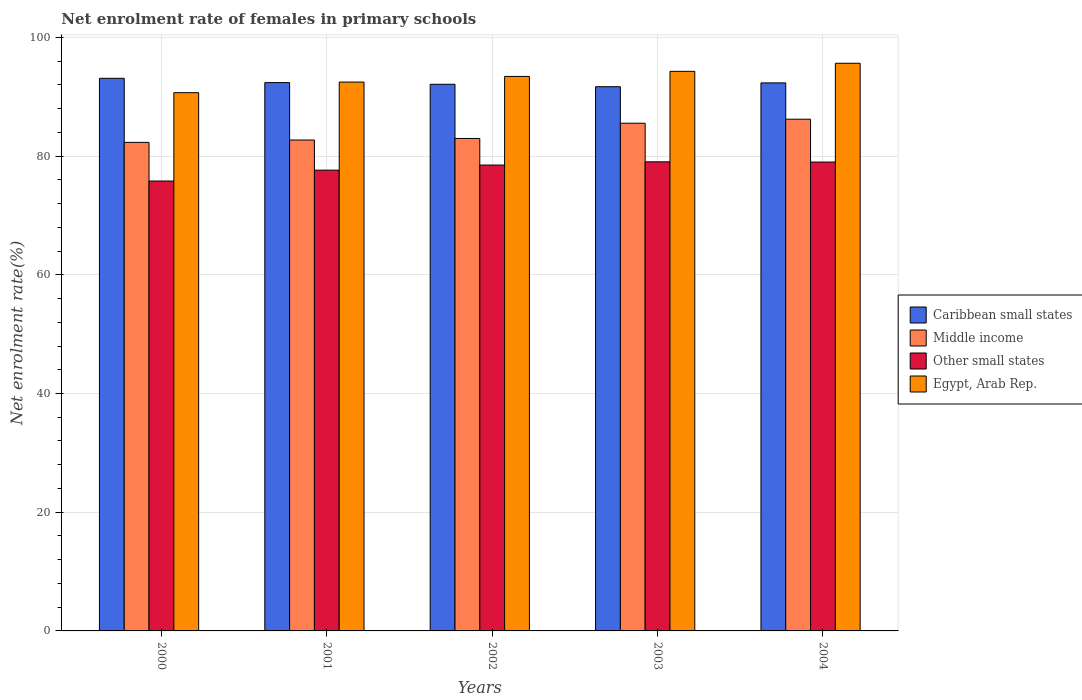Are the number of bars per tick equal to the number of legend labels?
Give a very brief answer. Yes. How many bars are there on the 3rd tick from the left?
Your response must be concise. 4. How many bars are there on the 4th tick from the right?
Ensure brevity in your answer.  4. In how many cases, is the number of bars for a given year not equal to the number of legend labels?
Give a very brief answer. 0. What is the net enrolment rate of females in primary schools in Other small states in 2002?
Ensure brevity in your answer.  78.48. Across all years, what is the maximum net enrolment rate of females in primary schools in Egypt, Arab Rep.?
Your response must be concise. 95.64. Across all years, what is the minimum net enrolment rate of females in primary schools in Egypt, Arab Rep.?
Your answer should be compact. 90.68. What is the total net enrolment rate of females in primary schools in Egypt, Arab Rep. in the graph?
Your answer should be compact. 466.47. What is the difference between the net enrolment rate of females in primary schools in Middle income in 2002 and that in 2004?
Your response must be concise. -3.25. What is the difference between the net enrolment rate of females in primary schools in Other small states in 2000 and the net enrolment rate of females in primary schools in Egypt, Arab Rep. in 2003?
Keep it short and to the point. -18.48. What is the average net enrolment rate of females in primary schools in Middle income per year?
Your answer should be very brief. 83.94. In the year 2001, what is the difference between the net enrolment rate of females in primary schools in Egypt, Arab Rep. and net enrolment rate of females in primary schools in Caribbean small states?
Keep it short and to the point. 0.09. What is the ratio of the net enrolment rate of females in primary schools in Caribbean small states in 2002 to that in 2003?
Offer a terse response. 1. What is the difference between the highest and the second highest net enrolment rate of females in primary schools in Caribbean small states?
Give a very brief answer. 0.72. What is the difference between the highest and the lowest net enrolment rate of females in primary schools in Caribbean small states?
Offer a very short reply. 1.41. Is the sum of the net enrolment rate of females in primary schools in Other small states in 2002 and 2004 greater than the maximum net enrolment rate of females in primary schools in Caribbean small states across all years?
Provide a short and direct response. Yes. What does the 2nd bar from the left in 2000 represents?
Provide a short and direct response. Middle income. What does the 1st bar from the right in 2000 represents?
Make the answer very short. Egypt, Arab Rep. How many bars are there?
Provide a succinct answer. 20. Are all the bars in the graph horizontal?
Your response must be concise. No. Are the values on the major ticks of Y-axis written in scientific E-notation?
Make the answer very short. No. Does the graph contain grids?
Offer a terse response. Yes. How are the legend labels stacked?
Provide a short and direct response. Vertical. What is the title of the graph?
Provide a succinct answer. Net enrolment rate of females in primary schools. Does "Germany" appear as one of the legend labels in the graph?
Your answer should be very brief. No. What is the label or title of the Y-axis?
Ensure brevity in your answer.  Net enrolment rate(%). What is the Net enrolment rate(%) of Caribbean small states in 2000?
Make the answer very short. 93.1. What is the Net enrolment rate(%) of Middle income in 2000?
Your answer should be compact. 82.31. What is the Net enrolment rate(%) in Other small states in 2000?
Keep it short and to the point. 75.79. What is the Net enrolment rate(%) in Egypt, Arab Rep. in 2000?
Make the answer very short. 90.68. What is the Net enrolment rate(%) in Caribbean small states in 2001?
Keep it short and to the point. 92.38. What is the Net enrolment rate(%) of Middle income in 2001?
Your response must be concise. 82.7. What is the Net enrolment rate(%) in Other small states in 2001?
Offer a very short reply. 77.63. What is the Net enrolment rate(%) in Egypt, Arab Rep. in 2001?
Your response must be concise. 92.46. What is the Net enrolment rate(%) of Caribbean small states in 2002?
Ensure brevity in your answer.  92.09. What is the Net enrolment rate(%) of Middle income in 2002?
Your response must be concise. 82.97. What is the Net enrolment rate(%) of Other small states in 2002?
Offer a very short reply. 78.48. What is the Net enrolment rate(%) in Egypt, Arab Rep. in 2002?
Offer a terse response. 93.42. What is the Net enrolment rate(%) in Caribbean small states in 2003?
Keep it short and to the point. 91.69. What is the Net enrolment rate(%) in Middle income in 2003?
Ensure brevity in your answer.  85.53. What is the Net enrolment rate(%) in Other small states in 2003?
Your answer should be compact. 79.03. What is the Net enrolment rate(%) of Egypt, Arab Rep. in 2003?
Your answer should be very brief. 94.27. What is the Net enrolment rate(%) in Caribbean small states in 2004?
Give a very brief answer. 92.33. What is the Net enrolment rate(%) of Middle income in 2004?
Your response must be concise. 86.21. What is the Net enrolment rate(%) of Other small states in 2004?
Give a very brief answer. 78.99. What is the Net enrolment rate(%) of Egypt, Arab Rep. in 2004?
Ensure brevity in your answer.  95.64. Across all years, what is the maximum Net enrolment rate(%) in Caribbean small states?
Give a very brief answer. 93.1. Across all years, what is the maximum Net enrolment rate(%) in Middle income?
Give a very brief answer. 86.21. Across all years, what is the maximum Net enrolment rate(%) in Other small states?
Your response must be concise. 79.03. Across all years, what is the maximum Net enrolment rate(%) of Egypt, Arab Rep.?
Provide a short and direct response. 95.64. Across all years, what is the minimum Net enrolment rate(%) in Caribbean small states?
Provide a short and direct response. 91.69. Across all years, what is the minimum Net enrolment rate(%) of Middle income?
Make the answer very short. 82.31. Across all years, what is the minimum Net enrolment rate(%) of Other small states?
Ensure brevity in your answer.  75.79. Across all years, what is the minimum Net enrolment rate(%) of Egypt, Arab Rep.?
Make the answer very short. 90.68. What is the total Net enrolment rate(%) of Caribbean small states in the graph?
Make the answer very short. 461.58. What is the total Net enrolment rate(%) in Middle income in the graph?
Your response must be concise. 419.72. What is the total Net enrolment rate(%) in Other small states in the graph?
Ensure brevity in your answer.  389.93. What is the total Net enrolment rate(%) of Egypt, Arab Rep. in the graph?
Keep it short and to the point. 466.47. What is the difference between the Net enrolment rate(%) of Caribbean small states in 2000 and that in 2001?
Offer a terse response. 0.72. What is the difference between the Net enrolment rate(%) of Middle income in 2000 and that in 2001?
Give a very brief answer. -0.4. What is the difference between the Net enrolment rate(%) of Other small states in 2000 and that in 2001?
Ensure brevity in your answer.  -1.83. What is the difference between the Net enrolment rate(%) of Egypt, Arab Rep. in 2000 and that in 2001?
Provide a succinct answer. -1.79. What is the difference between the Net enrolment rate(%) of Middle income in 2000 and that in 2002?
Give a very brief answer. -0.66. What is the difference between the Net enrolment rate(%) of Other small states in 2000 and that in 2002?
Provide a short and direct response. -2.69. What is the difference between the Net enrolment rate(%) in Egypt, Arab Rep. in 2000 and that in 2002?
Make the answer very short. -2.74. What is the difference between the Net enrolment rate(%) of Caribbean small states in 2000 and that in 2003?
Make the answer very short. 1.41. What is the difference between the Net enrolment rate(%) of Middle income in 2000 and that in 2003?
Make the answer very short. -3.23. What is the difference between the Net enrolment rate(%) in Other small states in 2000 and that in 2003?
Give a very brief answer. -3.24. What is the difference between the Net enrolment rate(%) in Egypt, Arab Rep. in 2000 and that in 2003?
Offer a very short reply. -3.6. What is the difference between the Net enrolment rate(%) in Caribbean small states in 2000 and that in 2004?
Ensure brevity in your answer.  0.77. What is the difference between the Net enrolment rate(%) in Middle income in 2000 and that in 2004?
Keep it short and to the point. -3.9. What is the difference between the Net enrolment rate(%) of Other small states in 2000 and that in 2004?
Provide a short and direct response. -3.2. What is the difference between the Net enrolment rate(%) of Egypt, Arab Rep. in 2000 and that in 2004?
Your response must be concise. -4.96. What is the difference between the Net enrolment rate(%) of Caribbean small states in 2001 and that in 2002?
Provide a short and direct response. 0.28. What is the difference between the Net enrolment rate(%) of Middle income in 2001 and that in 2002?
Offer a terse response. -0.26. What is the difference between the Net enrolment rate(%) of Other small states in 2001 and that in 2002?
Make the answer very short. -0.86. What is the difference between the Net enrolment rate(%) of Egypt, Arab Rep. in 2001 and that in 2002?
Your answer should be compact. -0.95. What is the difference between the Net enrolment rate(%) of Caribbean small states in 2001 and that in 2003?
Your answer should be very brief. 0.69. What is the difference between the Net enrolment rate(%) of Middle income in 2001 and that in 2003?
Your response must be concise. -2.83. What is the difference between the Net enrolment rate(%) in Other small states in 2001 and that in 2003?
Your response must be concise. -1.4. What is the difference between the Net enrolment rate(%) of Egypt, Arab Rep. in 2001 and that in 2003?
Make the answer very short. -1.81. What is the difference between the Net enrolment rate(%) of Caribbean small states in 2001 and that in 2004?
Offer a terse response. 0.05. What is the difference between the Net enrolment rate(%) of Middle income in 2001 and that in 2004?
Ensure brevity in your answer.  -3.51. What is the difference between the Net enrolment rate(%) in Other small states in 2001 and that in 2004?
Your response must be concise. -1.36. What is the difference between the Net enrolment rate(%) of Egypt, Arab Rep. in 2001 and that in 2004?
Keep it short and to the point. -3.17. What is the difference between the Net enrolment rate(%) in Caribbean small states in 2002 and that in 2003?
Your answer should be compact. 0.41. What is the difference between the Net enrolment rate(%) in Middle income in 2002 and that in 2003?
Offer a terse response. -2.57. What is the difference between the Net enrolment rate(%) in Other small states in 2002 and that in 2003?
Keep it short and to the point. -0.55. What is the difference between the Net enrolment rate(%) of Egypt, Arab Rep. in 2002 and that in 2003?
Offer a very short reply. -0.86. What is the difference between the Net enrolment rate(%) in Caribbean small states in 2002 and that in 2004?
Offer a terse response. -0.23. What is the difference between the Net enrolment rate(%) in Middle income in 2002 and that in 2004?
Make the answer very short. -3.25. What is the difference between the Net enrolment rate(%) in Other small states in 2002 and that in 2004?
Give a very brief answer. -0.51. What is the difference between the Net enrolment rate(%) of Egypt, Arab Rep. in 2002 and that in 2004?
Make the answer very short. -2.22. What is the difference between the Net enrolment rate(%) in Caribbean small states in 2003 and that in 2004?
Offer a terse response. -0.64. What is the difference between the Net enrolment rate(%) of Middle income in 2003 and that in 2004?
Keep it short and to the point. -0.68. What is the difference between the Net enrolment rate(%) of Other small states in 2003 and that in 2004?
Your answer should be compact. 0.04. What is the difference between the Net enrolment rate(%) in Egypt, Arab Rep. in 2003 and that in 2004?
Offer a terse response. -1.36. What is the difference between the Net enrolment rate(%) in Caribbean small states in 2000 and the Net enrolment rate(%) in Middle income in 2001?
Offer a very short reply. 10.39. What is the difference between the Net enrolment rate(%) in Caribbean small states in 2000 and the Net enrolment rate(%) in Other small states in 2001?
Ensure brevity in your answer.  15.47. What is the difference between the Net enrolment rate(%) in Caribbean small states in 2000 and the Net enrolment rate(%) in Egypt, Arab Rep. in 2001?
Give a very brief answer. 0.63. What is the difference between the Net enrolment rate(%) of Middle income in 2000 and the Net enrolment rate(%) of Other small states in 2001?
Make the answer very short. 4.68. What is the difference between the Net enrolment rate(%) in Middle income in 2000 and the Net enrolment rate(%) in Egypt, Arab Rep. in 2001?
Your answer should be compact. -10.16. What is the difference between the Net enrolment rate(%) in Other small states in 2000 and the Net enrolment rate(%) in Egypt, Arab Rep. in 2001?
Provide a succinct answer. -16.67. What is the difference between the Net enrolment rate(%) in Caribbean small states in 2000 and the Net enrolment rate(%) in Middle income in 2002?
Your answer should be very brief. 10.13. What is the difference between the Net enrolment rate(%) in Caribbean small states in 2000 and the Net enrolment rate(%) in Other small states in 2002?
Your answer should be compact. 14.61. What is the difference between the Net enrolment rate(%) of Caribbean small states in 2000 and the Net enrolment rate(%) of Egypt, Arab Rep. in 2002?
Ensure brevity in your answer.  -0.32. What is the difference between the Net enrolment rate(%) of Middle income in 2000 and the Net enrolment rate(%) of Other small states in 2002?
Provide a succinct answer. 3.82. What is the difference between the Net enrolment rate(%) of Middle income in 2000 and the Net enrolment rate(%) of Egypt, Arab Rep. in 2002?
Your response must be concise. -11.11. What is the difference between the Net enrolment rate(%) of Other small states in 2000 and the Net enrolment rate(%) of Egypt, Arab Rep. in 2002?
Your answer should be compact. -17.62. What is the difference between the Net enrolment rate(%) of Caribbean small states in 2000 and the Net enrolment rate(%) of Middle income in 2003?
Offer a terse response. 7.56. What is the difference between the Net enrolment rate(%) of Caribbean small states in 2000 and the Net enrolment rate(%) of Other small states in 2003?
Provide a succinct answer. 14.07. What is the difference between the Net enrolment rate(%) in Caribbean small states in 2000 and the Net enrolment rate(%) in Egypt, Arab Rep. in 2003?
Ensure brevity in your answer.  -1.18. What is the difference between the Net enrolment rate(%) of Middle income in 2000 and the Net enrolment rate(%) of Other small states in 2003?
Ensure brevity in your answer.  3.28. What is the difference between the Net enrolment rate(%) of Middle income in 2000 and the Net enrolment rate(%) of Egypt, Arab Rep. in 2003?
Offer a terse response. -11.97. What is the difference between the Net enrolment rate(%) in Other small states in 2000 and the Net enrolment rate(%) in Egypt, Arab Rep. in 2003?
Make the answer very short. -18.48. What is the difference between the Net enrolment rate(%) in Caribbean small states in 2000 and the Net enrolment rate(%) in Middle income in 2004?
Give a very brief answer. 6.88. What is the difference between the Net enrolment rate(%) of Caribbean small states in 2000 and the Net enrolment rate(%) of Other small states in 2004?
Provide a succinct answer. 14.11. What is the difference between the Net enrolment rate(%) in Caribbean small states in 2000 and the Net enrolment rate(%) in Egypt, Arab Rep. in 2004?
Your answer should be compact. -2.54. What is the difference between the Net enrolment rate(%) in Middle income in 2000 and the Net enrolment rate(%) in Other small states in 2004?
Ensure brevity in your answer.  3.32. What is the difference between the Net enrolment rate(%) in Middle income in 2000 and the Net enrolment rate(%) in Egypt, Arab Rep. in 2004?
Your answer should be very brief. -13.33. What is the difference between the Net enrolment rate(%) of Other small states in 2000 and the Net enrolment rate(%) of Egypt, Arab Rep. in 2004?
Offer a very short reply. -19.84. What is the difference between the Net enrolment rate(%) of Caribbean small states in 2001 and the Net enrolment rate(%) of Middle income in 2002?
Provide a succinct answer. 9.41. What is the difference between the Net enrolment rate(%) in Caribbean small states in 2001 and the Net enrolment rate(%) in Other small states in 2002?
Your answer should be compact. 13.89. What is the difference between the Net enrolment rate(%) in Caribbean small states in 2001 and the Net enrolment rate(%) in Egypt, Arab Rep. in 2002?
Offer a very short reply. -1.04. What is the difference between the Net enrolment rate(%) in Middle income in 2001 and the Net enrolment rate(%) in Other small states in 2002?
Provide a succinct answer. 4.22. What is the difference between the Net enrolment rate(%) of Middle income in 2001 and the Net enrolment rate(%) of Egypt, Arab Rep. in 2002?
Your answer should be very brief. -10.71. What is the difference between the Net enrolment rate(%) in Other small states in 2001 and the Net enrolment rate(%) in Egypt, Arab Rep. in 2002?
Ensure brevity in your answer.  -15.79. What is the difference between the Net enrolment rate(%) in Caribbean small states in 2001 and the Net enrolment rate(%) in Middle income in 2003?
Provide a succinct answer. 6.84. What is the difference between the Net enrolment rate(%) in Caribbean small states in 2001 and the Net enrolment rate(%) in Other small states in 2003?
Provide a succinct answer. 13.34. What is the difference between the Net enrolment rate(%) in Caribbean small states in 2001 and the Net enrolment rate(%) in Egypt, Arab Rep. in 2003?
Ensure brevity in your answer.  -1.9. What is the difference between the Net enrolment rate(%) in Middle income in 2001 and the Net enrolment rate(%) in Other small states in 2003?
Your answer should be very brief. 3.67. What is the difference between the Net enrolment rate(%) of Middle income in 2001 and the Net enrolment rate(%) of Egypt, Arab Rep. in 2003?
Keep it short and to the point. -11.57. What is the difference between the Net enrolment rate(%) in Other small states in 2001 and the Net enrolment rate(%) in Egypt, Arab Rep. in 2003?
Provide a succinct answer. -16.65. What is the difference between the Net enrolment rate(%) of Caribbean small states in 2001 and the Net enrolment rate(%) of Middle income in 2004?
Your answer should be compact. 6.16. What is the difference between the Net enrolment rate(%) of Caribbean small states in 2001 and the Net enrolment rate(%) of Other small states in 2004?
Give a very brief answer. 13.38. What is the difference between the Net enrolment rate(%) of Caribbean small states in 2001 and the Net enrolment rate(%) of Egypt, Arab Rep. in 2004?
Keep it short and to the point. -3.26. What is the difference between the Net enrolment rate(%) of Middle income in 2001 and the Net enrolment rate(%) of Other small states in 2004?
Keep it short and to the point. 3.71. What is the difference between the Net enrolment rate(%) in Middle income in 2001 and the Net enrolment rate(%) in Egypt, Arab Rep. in 2004?
Your answer should be very brief. -12.93. What is the difference between the Net enrolment rate(%) of Other small states in 2001 and the Net enrolment rate(%) of Egypt, Arab Rep. in 2004?
Offer a terse response. -18.01. What is the difference between the Net enrolment rate(%) in Caribbean small states in 2002 and the Net enrolment rate(%) in Middle income in 2003?
Ensure brevity in your answer.  6.56. What is the difference between the Net enrolment rate(%) in Caribbean small states in 2002 and the Net enrolment rate(%) in Other small states in 2003?
Offer a very short reply. 13.06. What is the difference between the Net enrolment rate(%) in Caribbean small states in 2002 and the Net enrolment rate(%) in Egypt, Arab Rep. in 2003?
Your answer should be very brief. -2.18. What is the difference between the Net enrolment rate(%) in Middle income in 2002 and the Net enrolment rate(%) in Other small states in 2003?
Your response must be concise. 3.94. What is the difference between the Net enrolment rate(%) of Middle income in 2002 and the Net enrolment rate(%) of Egypt, Arab Rep. in 2003?
Give a very brief answer. -11.31. What is the difference between the Net enrolment rate(%) in Other small states in 2002 and the Net enrolment rate(%) in Egypt, Arab Rep. in 2003?
Your answer should be compact. -15.79. What is the difference between the Net enrolment rate(%) of Caribbean small states in 2002 and the Net enrolment rate(%) of Middle income in 2004?
Give a very brief answer. 5.88. What is the difference between the Net enrolment rate(%) in Caribbean small states in 2002 and the Net enrolment rate(%) in Other small states in 2004?
Ensure brevity in your answer.  13.1. What is the difference between the Net enrolment rate(%) of Caribbean small states in 2002 and the Net enrolment rate(%) of Egypt, Arab Rep. in 2004?
Provide a short and direct response. -3.54. What is the difference between the Net enrolment rate(%) in Middle income in 2002 and the Net enrolment rate(%) in Other small states in 2004?
Your answer should be very brief. 3.98. What is the difference between the Net enrolment rate(%) of Middle income in 2002 and the Net enrolment rate(%) of Egypt, Arab Rep. in 2004?
Ensure brevity in your answer.  -12.67. What is the difference between the Net enrolment rate(%) of Other small states in 2002 and the Net enrolment rate(%) of Egypt, Arab Rep. in 2004?
Offer a terse response. -17.15. What is the difference between the Net enrolment rate(%) in Caribbean small states in 2003 and the Net enrolment rate(%) in Middle income in 2004?
Your answer should be very brief. 5.47. What is the difference between the Net enrolment rate(%) of Caribbean small states in 2003 and the Net enrolment rate(%) of Other small states in 2004?
Give a very brief answer. 12.69. What is the difference between the Net enrolment rate(%) of Caribbean small states in 2003 and the Net enrolment rate(%) of Egypt, Arab Rep. in 2004?
Provide a short and direct response. -3.95. What is the difference between the Net enrolment rate(%) in Middle income in 2003 and the Net enrolment rate(%) in Other small states in 2004?
Make the answer very short. 6.54. What is the difference between the Net enrolment rate(%) in Middle income in 2003 and the Net enrolment rate(%) in Egypt, Arab Rep. in 2004?
Give a very brief answer. -10.1. What is the difference between the Net enrolment rate(%) in Other small states in 2003 and the Net enrolment rate(%) in Egypt, Arab Rep. in 2004?
Provide a succinct answer. -16.6. What is the average Net enrolment rate(%) in Caribbean small states per year?
Provide a succinct answer. 92.32. What is the average Net enrolment rate(%) in Middle income per year?
Provide a succinct answer. 83.94. What is the average Net enrolment rate(%) in Other small states per year?
Give a very brief answer. 77.99. What is the average Net enrolment rate(%) in Egypt, Arab Rep. per year?
Give a very brief answer. 93.29. In the year 2000, what is the difference between the Net enrolment rate(%) of Caribbean small states and Net enrolment rate(%) of Middle income?
Keep it short and to the point. 10.79. In the year 2000, what is the difference between the Net enrolment rate(%) in Caribbean small states and Net enrolment rate(%) in Other small states?
Provide a short and direct response. 17.3. In the year 2000, what is the difference between the Net enrolment rate(%) in Caribbean small states and Net enrolment rate(%) in Egypt, Arab Rep.?
Keep it short and to the point. 2.42. In the year 2000, what is the difference between the Net enrolment rate(%) in Middle income and Net enrolment rate(%) in Other small states?
Keep it short and to the point. 6.51. In the year 2000, what is the difference between the Net enrolment rate(%) of Middle income and Net enrolment rate(%) of Egypt, Arab Rep.?
Your answer should be compact. -8.37. In the year 2000, what is the difference between the Net enrolment rate(%) in Other small states and Net enrolment rate(%) in Egypt, Arab Rep.?
Give a very brief answer. -14.88. In the year 2001, what is the difference between the Net enrolment rate(%) of Caribbean small states and Net enrolment rate(%) of Middle income?
Ensure brevity in your answer.  9.67. In the year 2001, what is the difference between the Net enrolment rate(%) in Caribbean small states and Net enrolment rate(%) in Other small states?
Your answer should be very brief. 14.75. In the year 2001, what is the difference between the Net enrolment rate(%) in Caribbean small states and Net enrolment rate(%) in Egypt, Arab Rep.?
Keep it short and to the point. -0.09. In the year 2001, what is the difference between the Net enrolment rate(%) in Middle income and Net enrolment rate(%) in Other small states?
Give a very brief answer. 5.08. In the year 2001, what is the difference between the Net enrolment rate(%) of Middle income and Net enrolment rate(%) of Egypt, Arab Rep.?
Your answer should be very brief. -9.76. In the year 2001, what is the difference between the Net enrolment rate(%) in Other small states and Net enrolment rate(%) in Egypt, Arab Rep.?
Provide a short and direct response. -14.84. In the year 2002, what is the difference between the Net enrolment rate(%) in Caribbean small states and Net enrolment rate(%) in Middle income?
Your answer should be compact. 9.13. In the year 2002, what is the difference between the Net enrolment rate(%) in Caribbean small states and Net enrolment rate(%) in Other small states?
Offer a terse response. 13.61. In the year 2002, what is the difference between the Net enrolment rate(%) of Caribbean small states and Net enrolment rate(%) of Egypt, Arab Rep.?
Give a very brief answer. -1.32. In the year 2002, what is the difference between the Net enrolment rate(%) in Middle income and Net enrolment rate(%) in Other small states?
Your answer should be compact. 4.48. In the year 2002, what is the difference between the Net enrolment rate(%) of Middle income and Net enrolment rate(%) of Egypt, Arab Rep.?
Keep it short and to the point. -10.45. In the year 2002, what is the difference between the Net enrolment rate(%) in Other small states and Net enrolment rate(%) in Egypt, Arab Rep.?
Keep it short and to the point. -14.93. In the year 2003, what is the difference between the Net enrolment rate(%) in Caribbean small states and Net enrolment rate(%) in Middle income?
Your answer should be compact. 6.15. In the year 2003, what is the difference between the Net enrolment rate(%) in Caribbean small states and Net enrolment rate(%) in Other small states?
Make the answer very short. 12.65. In the year 2003, what is the difference between the Net enrolment rate(%) in Caribbean small states and Net enrolment rate(%) in Egypt, Arab Rep.?
Provide a short and direct response. -2.59. In the year 2003, what is the difference between the Net enrolment rate(%) of Middle income and Net enrolment rate(%) of Other small states?
Keep it short and to the point. 6.5. In the year 2003, what is the difference between the Net enrolment rate(%) of Middle income and Net enrolment rate(%) of Egypt, Arab Rep.?
Offer a very short reply. -8.74. In the year 2003, what is the difference between the Net enrolment rate(%) in Other small states and Net enrolment rate(%) in Egypt, Arab Rep.?
Your answer should be very brief. -15.24. In the year 2004, what is the difference between the Net enrolment rate(%) in Caribbean small states and Net enrolment rate(%) in Middle income?
Give a very brief answer. 6.12. In the year 2004, what is the difference between the Net enrolment rate(%) in Caribbean small states and Net enrolment rate(%) in Other small states?
Ensure brevity in your answer.  13.34. In the year 2004, what is the difference between the Net enrolment rate(%) of Caribbean small states and Net enrolment rate(%) of Egypt, Arab Rep.?
Your response must be concise. -3.31. In the year 2004, what is the difference between the Net enrolment rate(%) in Middle income and Net enrolment rate(%) in Other small states?
Make the answer very short. 7.22. In the year 2004, what is the difference between the Net enrolment rate(%) of Middle income and Net enrolment rate(%) of Egypt, Arab Rep.?
Make the answer very short. -9.42. In the year 2004, what is the difference between the Net enrolment rate(%) in Other small states and Net enrolment rate(%) in Egypt, Arab Rep.?
Provide a succinct answer. -16.64. What is the ratio of the Net enrolment rate(%) of Other small states in 2000 to that in 2001?
Make the answer very short. 0.98. What is the ratio of the Net enrolment rate(%) in Egypt, Arab Rep. in 2000 to that in 2001?
Your answer should be very brief. 0.98. What is the ratio of the Net enrolment rate(%) of Caribbean small states in 2000 to that in 2002?
Ensure brevity in your answer.  1.01. What is the ratio of the Net enrolment rate(%) in Other small states in 2000 to that in 2002?
Offer a very short reply. 0.97. What is the ratio of the Net enrolment rate(%) of Egypt, Arab Rep. in 2000 to that in 2002?
Offer a very short reply. 0.97. What is the ratio of the Net enrolment rate(%) in Caribbean small states in 2000 to that in 2003?
Offer a terse response. 1.02. What is the ratio of the Net enrolment rate(%) in Middle income in 2000 to that in 2003?
Your answer should be very brief. 0.96. What is the ratio of the Net enrolment rate(%) of Egypt, Arab Rep. in 2000 to that in 2003?
Provide a short and direct response. 0.96. What is the ratio of the Net enrolment rate(%) in Caribbean small states in 2000 to that in 2004?
Keep it short and to the point. 1.01. What is the ratio of the Net enrolment rate(%) in Middle income in 2000 to that in 2004?
Offer a very short reply. 0.95. What is the ratio of the Net enrolment rate(%) of Other small states in 2000 to that in 2004?
Give a very brief answer. 0.96. What is the ratio of the Net enrolment rate(%) of Egypt, Arab Rep. in 2000 to that in 2004?
Ensure brevity in your answer.  0.95. What is the ratio of the Net enrolment rate(%) in Caribbean small states in 2001 to that in 2002?
Your response must be concise. 1. What is the ratio of the Net enrolment rate(%) of Middle income in 2001 to that in 2002?
Ensure brevity in your answer.  1. What is the ratio of the Net enrolment rate(%) of Other small states in 2001 to that in 2002?
Keep it short and to the point. 0.99. What is the ratio of the Net enrolment rate(%) of Egypt, Arab Rep. in 2001 to that in 2002?
Make the answer very short. 0.99. What is the ratio of the Net enrolment rate(%) of Caribbean small states in 2001 to that in 2003?
Offer a terse response. 1.01. What is the ratio of the Net enrolment rate(%) in Middle income in 2001 to that in 2003?
Offer a terse response. 0.97. What is the ratio of the Net enrolment rate(%) of Other small states in 2001 to that in 2003?
Ensure brevity in your answer.  0.98. What is the ratio of the Net enrolment rate(%) of Egypt, Arab Rep. in 2001 to that in 2003?
Your response must be concise. 0.98. What is the ratio of the Net enrolment rate(%) in Middle income in 2001 to that in 2004?
Keep it short and to the point. 0.96. What is the ratio of the Net enrolment rate(%) in Other small states in 2001 to that in 2004?
Give a very brief answer. 0.98. What is the ratio of the Net enrolment rate(%) of Egypt, Arab Rep. in 2001 to that in 2004?
Make the answer very short. 0.97. What is the ratio of the Net enrolment rate(%) in Middle income in 2002 to that in 2003?
Make the answer very short. 0.97. What is the ratio of the Net enrolment rate(%) of Other small states in 2002 to that in 2003?
Give a very brief answer. 0.99. What is the ratio of the Net enrolment rate(%) of Egypt, Arab Rep. in 2002 to that in 2003?
Make the answer very short. 0.99. What is the ratio of the Net enrolment rate(%) in Caribbean small states in 2002 to that in 2004?
Make the answer very short. 1. What is the ratio of the Net enrolment rate(%) in Middle income in 2002 to that in 2004?
Ensure brevity in your answer.  0.96. What is the ratio of the Net enrolment rate(%) of Other small states in 2002 to that in 2004?
Make the answer very short. 0.99. What is the ratio of the Net enrolment rate(%) in Egypt, Arab Rep. in 2002 to that in 2004?
Provide a succinct answer. 0.98. What is the ratio of the Net enrolment rate(%) in Middle income in 2003 to that in 2004?
Your response must be concise. 0.99. What is the ratio of the Net enrolment rate(%) in Egypt, Arab Rep. in 2003 to that in 2004?
Offer a very short reply. 0.99. What is the difference between the highest and the second highest Net enrolment rate(%) in Caribbean small states?
Provide a short and direct response. 0.72. What is the difference between the highest and the second highest Net enrolment rate(%) of Middle income?
Give a very brief answer. 0.68. What is the difference between the highest and the second highest Net enrolment rate(%) in Other small states?
Keep it short and to the point. 0.04. What is the difference between the highest and the second highest Net enrolment rate(%) of Egypt, Arab Rep.?
Your answer should be compact. 1.36. What is the difference between the highest and the lowest Net enrolment rate(%) in Caribbean small states?
Provide a succinct answer. 1.41. What is the difference between the highest and the lowest Net enrolment rate(%) of Middle income?
Your answer should be compact. 3.9. What is the difference between the highest and the lowest Net enrolment rate(%) in Other small states?
Ensure brevity in your answer.  3.24. What is the difference between the highest and the lowest Net enrolment rate(%) in Egypt, Arab Rep.?
Make the answer very short. 4.96. 